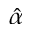Convert formula to latex. <formula><loc_0><loc_0><loc_500><loc_500>\hat { \alpha }</formula> 